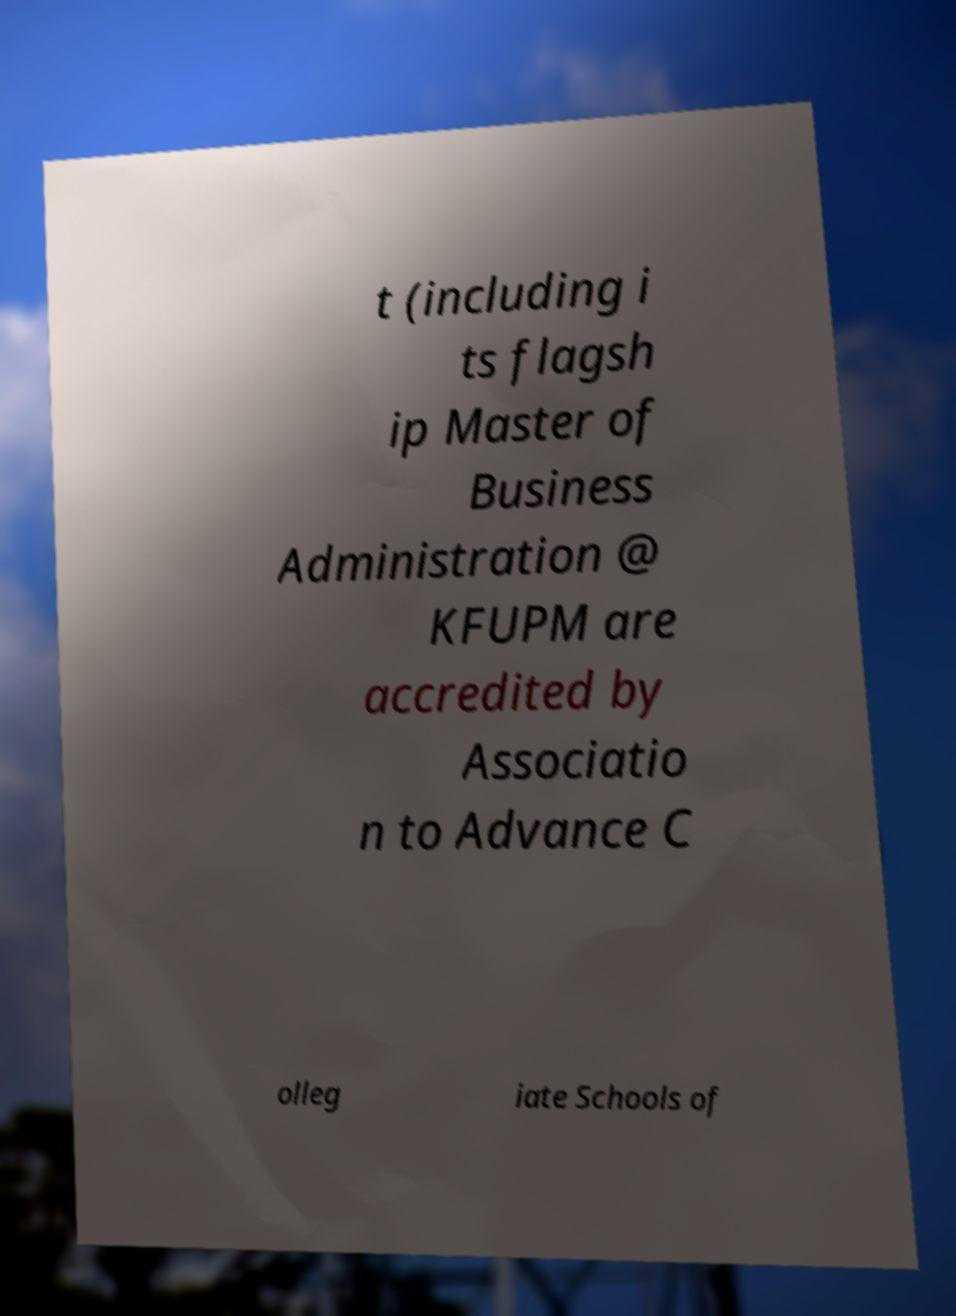Please identify and transcribe the text found in this image. t (including i ts flagsh ip Master of Business Administration @ KFUPM are accredited by Associatio n to Advance C olleg iate Schools of 